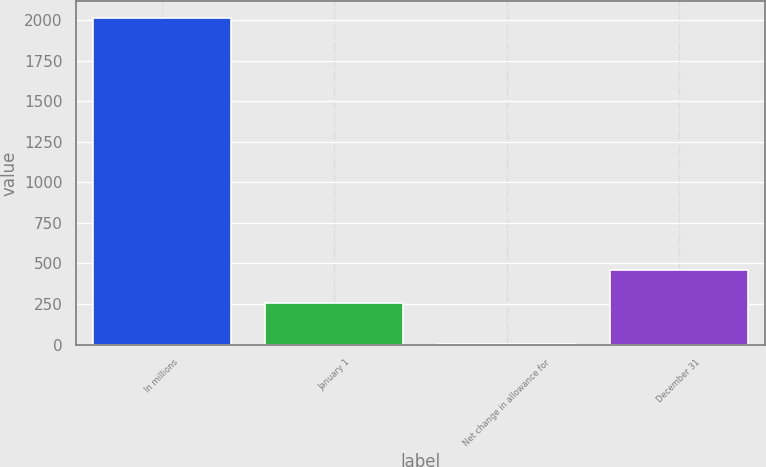<chart> <loc_0><loc_0><loc_500><loc_500><bar_chart><fcel>In millions<fcel>January 1<fcel>Net change in allowance for<fcel>December 31<nl><fcel>2015<fcel>259<fcel>2<fcel>460.3<nl></chart> 